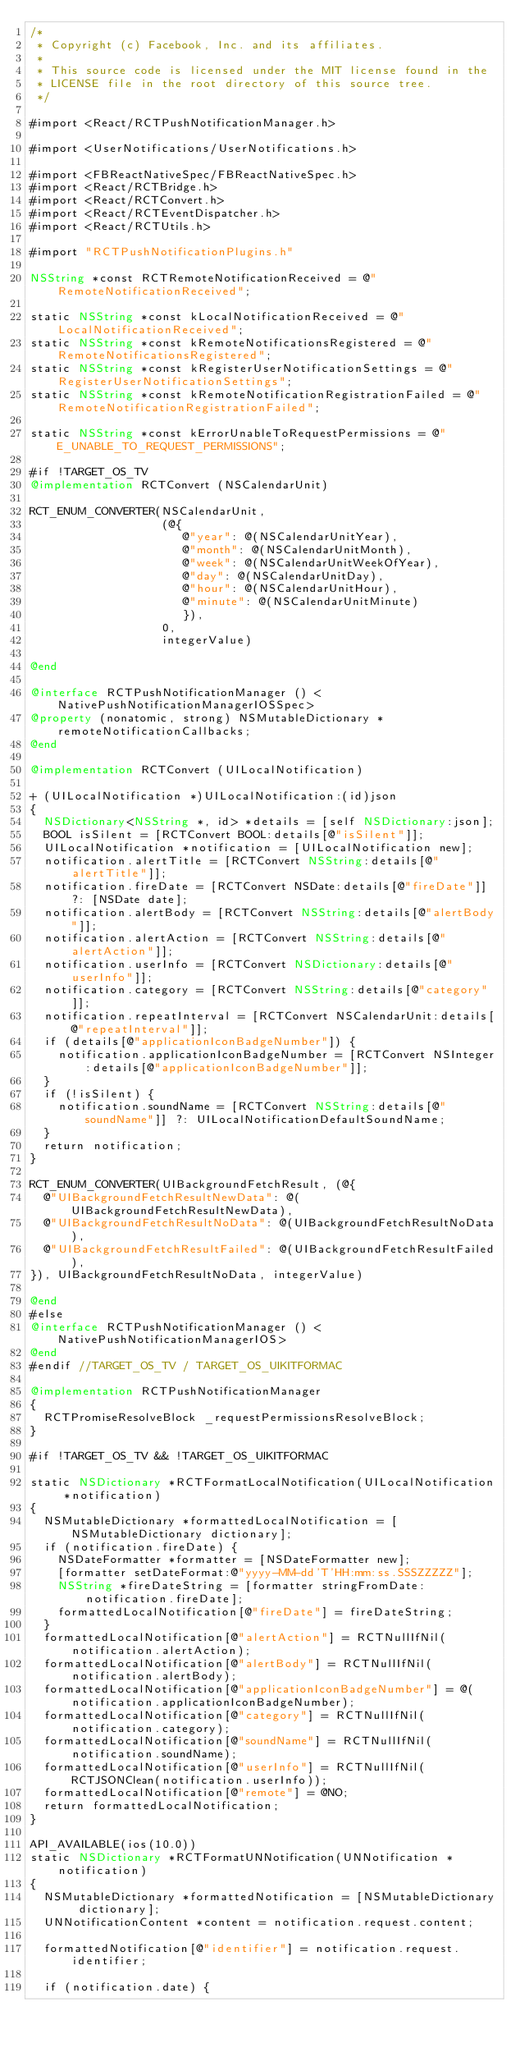Convert code to text. <code><loc_0><loc_0><loc_500><loc_500><_ObjectiveC_>/*
 * Copyright (c) Facebook, Inc. and its affiliates.
 *
 * This source code is licensed under the MIT license found in the
 * LICENSE file in the root directory of this source tree.
 */

#import <React/RCTPushNotificationManager.h>

#import <UserNotifications/UserNotifications.h>

#import <FBReactNativeSpec/FBReactNativeSpec.h>
#import <React/RCTBridge.h>
#import <React/RCTConvert.h>
#import <React/RCTEventDispatcher.h>
#import <React/RCTUtils.h>

#import "RCTPushNotificationPlugins.h"

NSString *const RCTRemoteNotificationReceived = @"RemoteNotificationReceived";

static NSString *const kLocalNotificationReceived = @"LocalNotificationReceived";
static NSString *const kRemoteNotificationsRegistered = @"RemoteNotificationsRegistered";
static NSString *const kRegisterUserNotificationSettings = @"RegisterUserNotificationSettings";
static NSString *const kRemoteNotificationRegistrationFailed = @"RemoteNotificationRegistrationFailed";

static NSString *const kErrorUnableToRequestPermissions = @"E_UNABLE_TO_REQUEST_PERMISSIONS";

#if !TARGET_OS_TV
@implementation RCTConvert (NSCalendarUnit)

RCT_ENUM_CONVERTER(NSCalendarUnit,
                   (@{
                      @"year": @(NSCalendarUnitYear),
                      @"month": @(NSCalendarUnitMonth),
                      @"week": @(NSCalendarUnitWeekOfYear),
                      @"day": @(NSCalendarUnitDay),
                      @"hour": @(NSCalendarUnitHour),
                      @"minute": @(NSCalendarUnitMinute)
                      }),
                   0,
                   integerValue)

@end

@interface RCTPushNotificationManager () <NativePushNotificationManagerIOSSpec>
@property (nonatomic, strong) NSMutableDictionary *remoteNotificationCallbacks;
@end

@implementation RCTConvert (UILocalNotification)

+ (UILocalNotification *)UILocalNotification:(id)json
{
  NSDictionary<NSString *, id> *details = [self NSDictionary:json];
  BOOL isSilent = [RCTConvert BOOL:details[@"isSilent"]];
  UILocalNotification *notification = [UILocalNotification new];
  notification.alertTitle = [RCTConvert NSString:details[@"alertTitle"]];
  notification.fireDate = [RCTConvert NSDate:details[@"fireDate"]] ?: [NSDate date];
  notification.alertBody = [RCTConvert NSString:details[@"alertBody"]];
  notification.alertAction = [RCTConvert NSString:details[@"alertAction"]];
  notification.userInfo = [RCTConvert NSDictionary:details[@"userInfo"]];
  notification.category = [RCTConvert NSString:details[@"category"]];
  notification.repeatInterval = [RCTConvert NSCalendarUnit:details[@"repeatInterval"]];
  if (details[@"applicationIconBadgeNumber"]) {
    notification.applicationIconBadgeNumber = [RCTConvert NSInteger:details[@"applicationIconBadgeNumber"]];
  }
  if (!isSilent) {
    notification.soundName = [RCTConvert NSString:details[@"soundName"]] ?: UILocalNotificationDefaultSoundName;
  }
  return notification;
}

RCT_ENUM_CONVERTER(UIBackgroundFetchResult, (@{
  @"UIBackgroundFetchResultNewData": @(UIBackgroundFetchResultNewData),
  @"UIBackgroundFetchResultNoData": @(UIBackgroundFetchResultNoData),
  @"UIBackgroundFetchResultFailed": @(UIBackgroundFetchResultFailed),
}), UIBackgroundFetchResultNoData, integerValue)

@end
#else
@interface RCTPushNotificationManager () <NativePushNotificationManagerIOS>
@end
#endif //TARGET_OS_TV / TARGET_OS_UIKITFORMAC

@implementation RCTPushNotificationManager
{
  RCTPromiseResolveBlock _requestPermissionsResolveBlock;
}

#if !TARGET_OS_TV && !TARGET_OS_UIKITFORMAC

static NSDictionary *RCTFormatLocalNotification(UILocalNotification *notification)
{
  NSMutableDictionary *formattedLocalNotification = [NSMutableDictionary dictionary];
  if (notification.fireDate) {
    NSDateFormatter *formatter = [NSDateFormatter new];
    [formatter setDateFormat:@"yyyy-MM-dd'T'HH:mm:ss.SSSZZZZZ"];
    NSString *fireDateString = [formatter stringFromDate:notification.fireDate];
    formattedLocalNotification[@"fireDate"] = fireDateString;
  }
  formattedLocalNotification[@"alertAction"] = RCTNullIfNil(notification.alertAction);
  formattedLocalNotification[@"alertBody"] = RCTNullIfNil(notification.alertBody);
  formattedLocalNotification[@"applicationIconBadgeNumber"] = @(notification.applicationIconBadgeNumber);
  formattedLocalNotification[@"category"] = RCTNullIfNil(notification.category);
  formattedLocalNotification[@"soundName"] = RCTNullIfNil(notification.soundName);
  formattedLocalNotification[@"userInfo"] = RCTNullIfNil(RCTJSONClean(notification.userInfo));
  formattedLocalNotification[@"remote"] = @NO;
  return formattedLocalNotification;
}

API_AVAILABLE(ios(10.0))
static NSDictionary *RCTFormatUNNotification(UNNotification *notification)
{
  NSMutableDictionary *formattedNotification = [NSMutableDictionary dictionary];
  UNNotificationContent *content = notification.request.content;

  formattedNotification[@"identifier"] = notification.request.identifier;

  if (notification.date) {</code> 